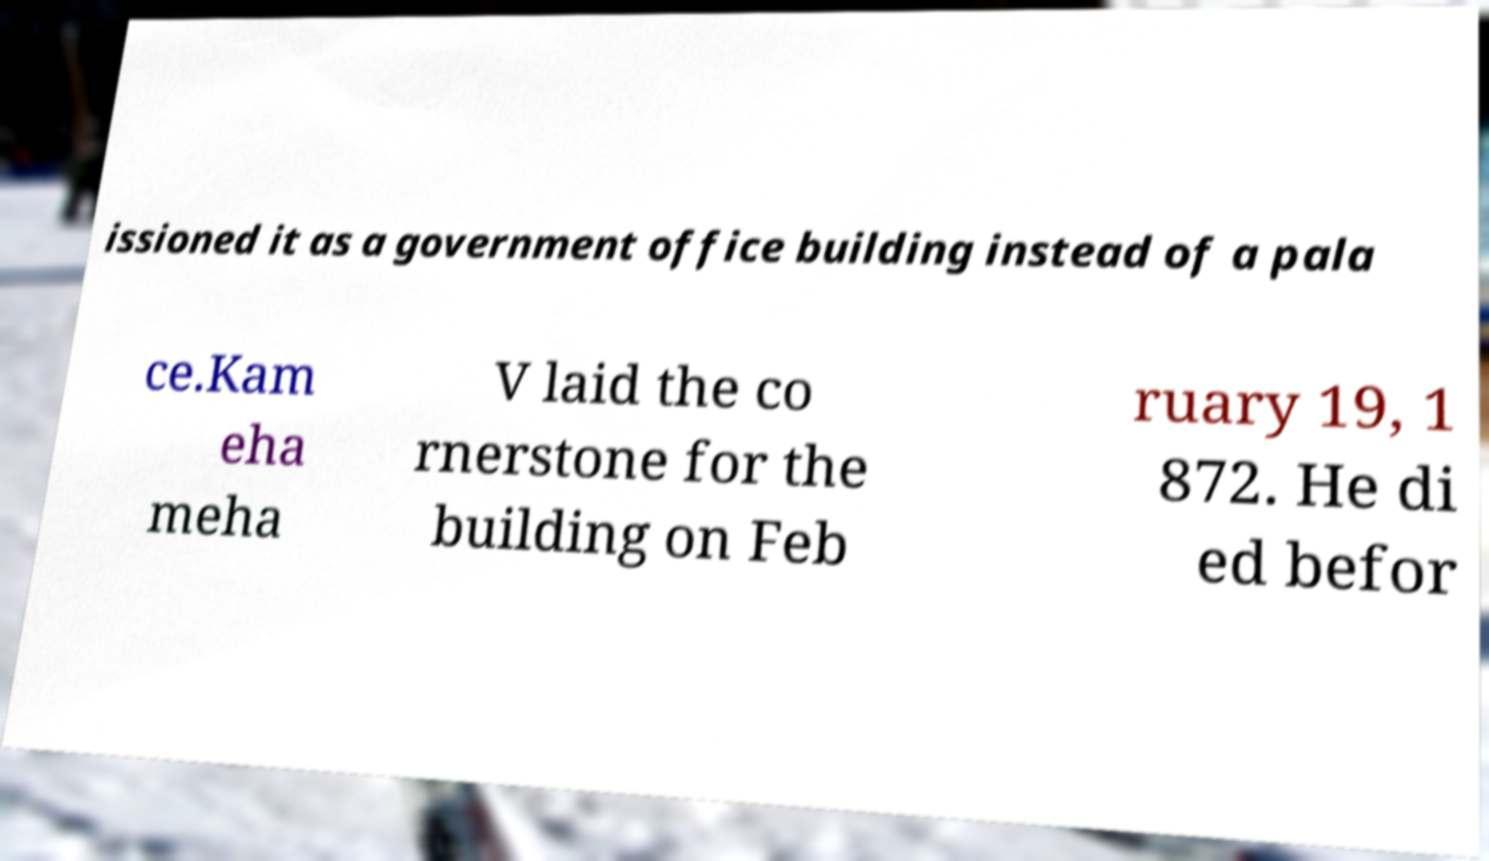Please identify and transcribe the text found in this image. issioned it as a government office building instead of a pala ce.Kam eha meha V laid the co rnerstone for the building on Feb ruary 19, 1 872. He di ed befor 